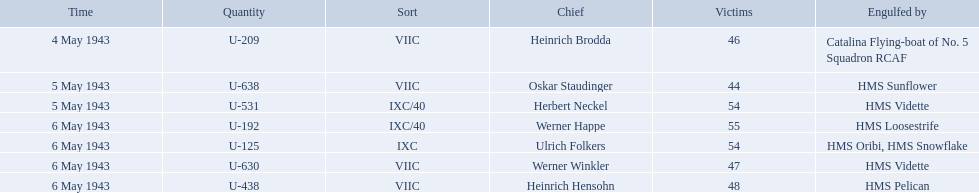Who were the captains in the ons 5 convoy? Heinrich Brodda, Oskar Staudinger, Herbert Neckel, Werner Happe, Ulrich Folkers, Werner Winkler, Heinrich Hensohn. Which ones lost their u-boat on may 5? Oskar Staudinger, Herbert Neckel. Of those, which one is not oskar staudinger? Herbert Neckel. Who are the captains of the u boats? Heinrich Brodda, Oskar Staudinger, Herbert Neckel, Werner Happe, Ulrich Folkers, Werner Winkler, Heinrich Hensohn. What are the dates the u boat captains were lost? 4 May 1943, 5 May 1943, 5 May 1943, 6 May 1943, 6 May 1943, 6 May 1943, 6 May 1943. Of these, which were lost on may 5? Oskar Staudinger, Herbert Neckel. Other than oskar staudinger, who else was lost on this day? Herbert Neckel. Who are all of the captains? Heinrich Brodda, Oskar Staudinger, Herbert Neckel, Werner Happe, Ulrich Folkers, Werner Winkler, Heinrich Hensohn. What sunk each of the captains? Catalina Flying-boat of No. 5 Squadron RCAF, HMS Sunflower, HMS Vidette, HMS Loosestrife, HMS Oribi, HMS Snowflake, HMS Vidette, HMS Pelican. Which was sunk by the hms pelican? Heinrich Hensohn. What is the list of ships under sunk by? Catalina Flying-boat of No. 5 Squadron RCAF, HMS Sunflower, HMS Vidette, HMS Loosestrife, HMS Oribi, HMS Snowflake, HMS Vidette, HMS Pelican. Which captains did hms pelican sink? Heinrich Hensohn. Which were the names of the sinkers of the convoys? Catalina Flying-boat of No. 5 Squadron RCAF, HMS Sunflower, HMS Vidette, HMS Loosestrife, HMS Oribi, HMS Snowflake, HMS Vidette, HMS Pelican. What captain was sunk by the hms pelican? Heinrich Hensohn. 